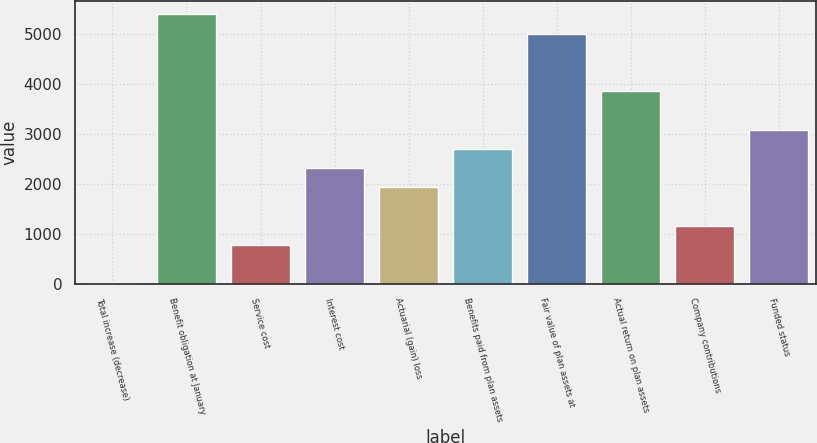<chart> <loc_0><loc_0><loc_500><loc_500><bar_chart><fcel>Total increase (decrease)<fcel>Benefit obligation at January<fcel>Service cost<fcel>Interest cost<fcel>Actuarial (gain) loss<fcel>Benefits paid from plan assets<fcel>Fair value of plan assets at<fcel>Actual return on plan assets<fcel>Company contributions<fcel>Funded status<nl><fcel>11<fcel>5401<fcel>781<fcel>2321<fcel>1936<fcel>2706<fcel>5016<fcel>3861<fcel>1166<fcel>3091<nl></chart> 